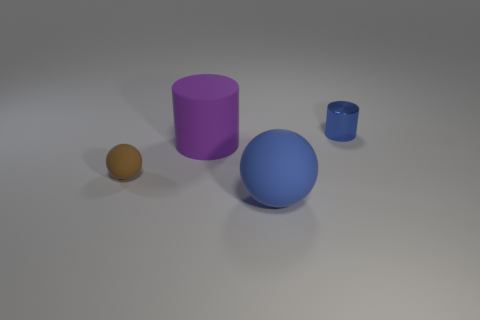Add 2 blue metal objects. How many objects exist? 6 Subtract 0 red spheres. How many objects are left? 4 Subtract all big cyan metallic spheres. Subtract all small brown objects. How many objects are left? 3 Add 3 large blue balls. How many large blue balls are left? 4 Add 2 blue balls. How many blue balls exist? 3 